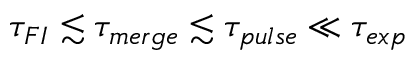Convert formula to latex. <formula><loc_0><loc_0><loc_500><loc_500>\tau _ { F I } \lesssim \tau _ { m e r g e } \lesssim \tau _ { p u l s e } \ll \tau _ { e x p }</formula> 